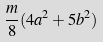<formula> <loc_0><loc_0><loc_500><loc_500>\frac { m } { 8 } ( 4 a ^ { 2 } + 5 b ^ { 2 } )</formula> 